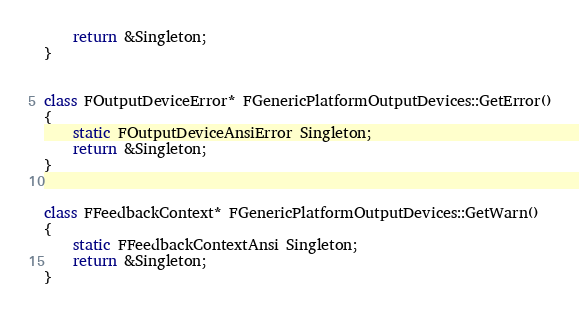<code> <loc_0><loc_0><loc_500><loc_500><_C++_>	return &Singleton;
}


class FOutputDeviceError* FGenericPlatformOutputDevices::GetError()
{
	static FOutputDeviceAnsiError Singleton;
	return &Singleton;
}


class FFeedbackContext* FGenericPlatformOutputDevices::GetWarn()
{
	static FFeedbackContextAnsi Singleton;
	return &Singleton;
}
</code> 